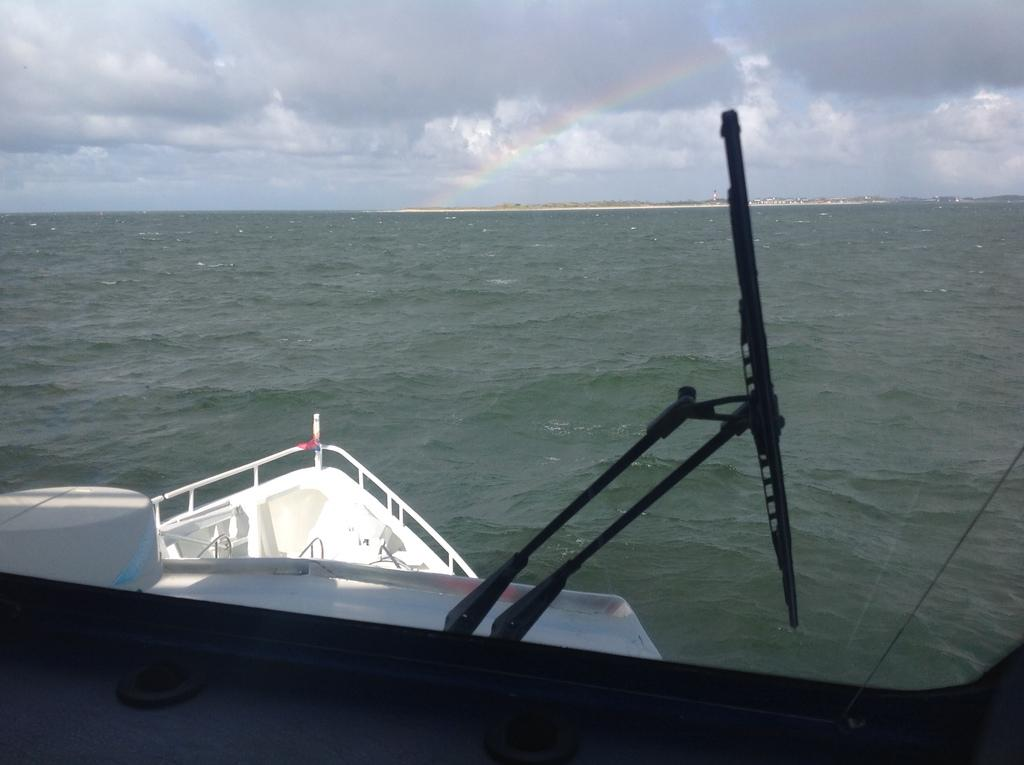What is the main subject in the foreground of the image? There is a ship in the foreground of the image. What can be seen on the ship? There are objects on the ship. What type of water body is visible in the background of the image? There is a river in the background of the image. What is visible at the top of the image? The sky is visible at the top of the image. Can you see a beggar wearing a crown in the image? There is no beggar or crown present in the image. What type of pleasure can be seen on the faces of the people on the ship? There are no people visible on the ship in the image, so their expressions cannot be determined. 